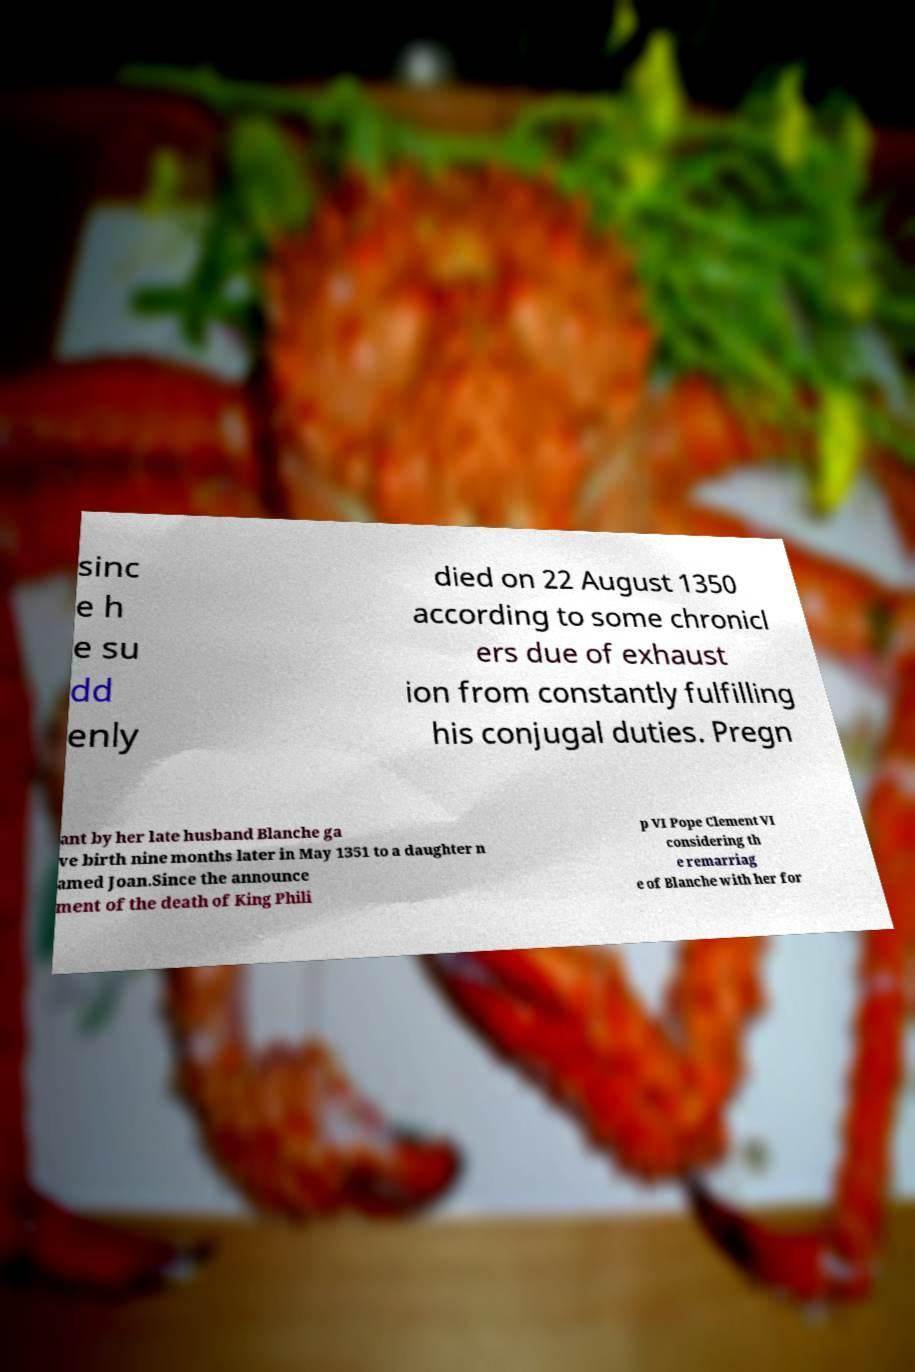What messages or text are displayed in this image? I need them in a readable, typed format. sinc e h e su dd enly died on 22 August 1350 according to some chronicl ers due of exhaust ion from constantly fulfilling his conjugal duties. Pregn ant by her late husband Blanche ga ve birth nine months later in May 1351 to a daughter n amed Joan.Since the announce ment of the death of King Phili p VI Pope Clement VI considering th e remarriag e of Blanche with her for 